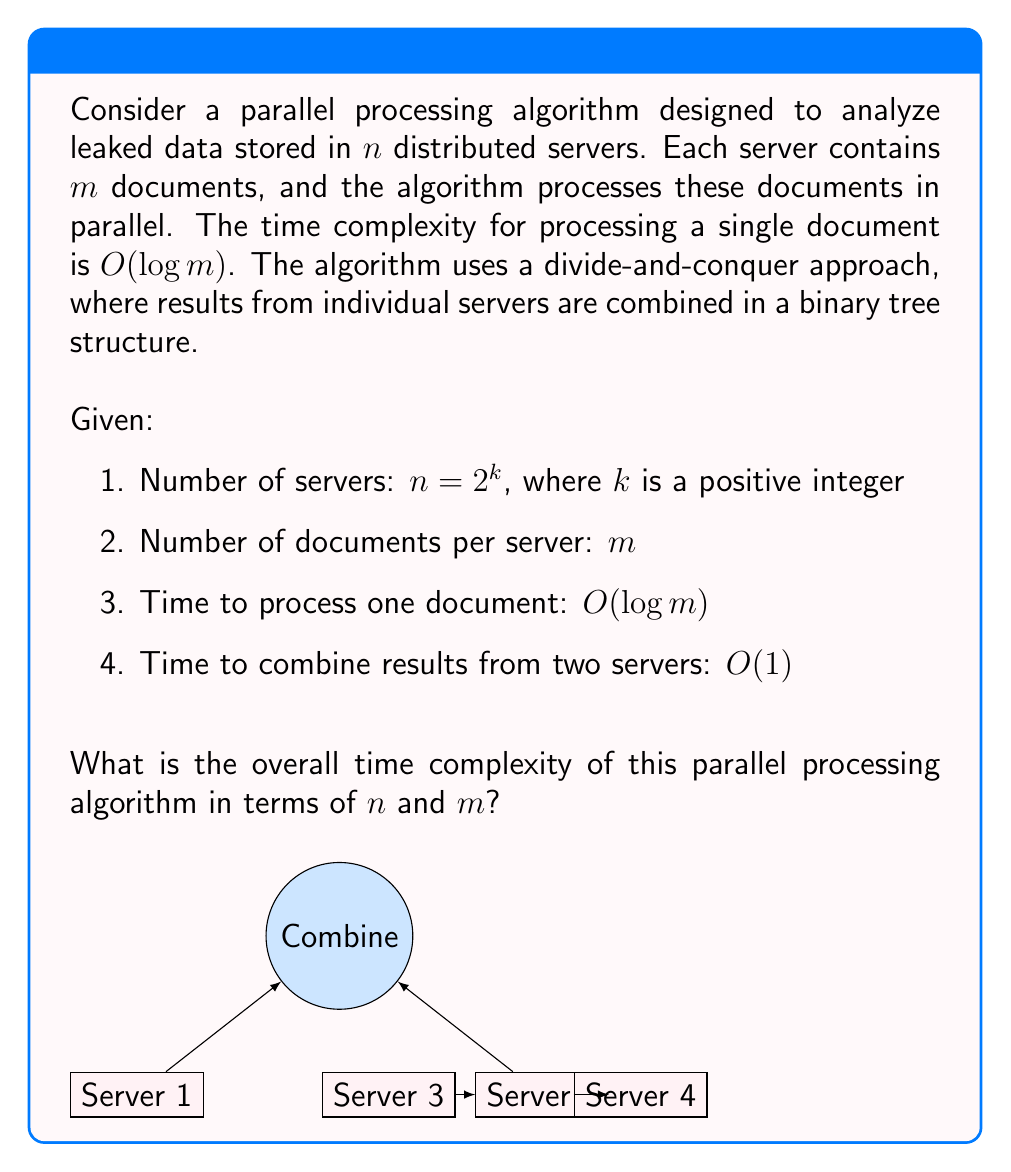Help me with this question. Let's analyze this problem step by step:

1. Processing documents on each server:
   - Each server processes $m$ documents in parallel
   - Time complexity for processing one document: $O(\log m)$
   - Total time for processing all documents on one server: $O(\log m)$

2. Combining results:
   - The servers are combined in a binary tree structure
   - Number of levels in the binary tree: $\log_2 n = \log_2 2^k = k$
   - Time to combine results at each level: $O(1)$

3. Overall time complexity:
   - The algorithm consists of two main phases: processing and combining
   - Processing phase time: $O(\log m)$
   - Combining phase time: $O(\log n)$ (as there are $\log n$ levels, each taking $O(1)$ time)
   - Total time: $\max(O(\log m), O(\log n))$

4. Simplifying the result:
   - We know that $n = 2^k$, so $\log n = k$
   - The overall time complexity is $O(\max(\log m, \log n))$
   - This can be written as $O(\log \max(m, n))$

Therefore, the overall time complexity of the parallel processing algorithm is $O(\log \max(m, n))$.
Answer: $O(\log \max(m, n))$ 